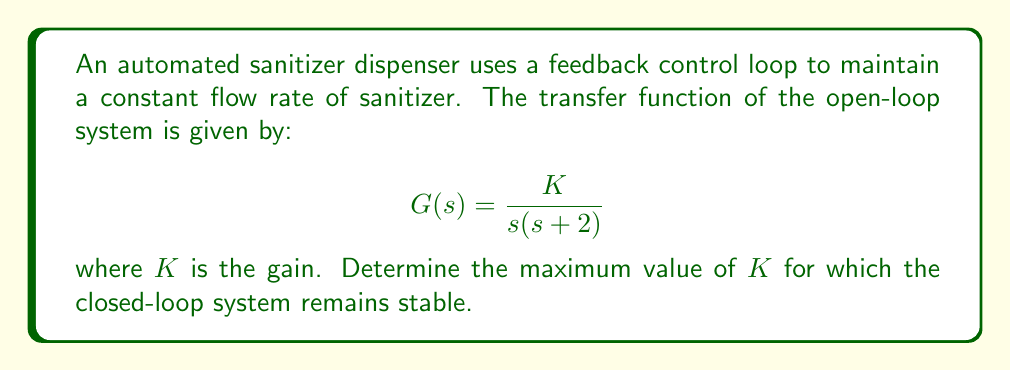Can you solve this math problem? To determine the stability of the closed-loop system, we need to analyze the characteristic equation using the Routh-Hurwitz stability criterion. 

1. First, let's form the closed-loop transfer function:

   $$H(s) = \frac{G(s)}{1 + G(s)} = \frac{\frac{K}{s(s + 2)}}{1 + \frac{K}{s(s + 2)}} = \frac{K}{s^2 + 2s + K}$$

2. The characteristic equation is the denominator of $H(s)$ set to zero:

   $$s^2 + 2s + K = 0$$

3. Now, we form the Routh array:

   $$\begin{array}{c|c}
   s^2 & 1 & K \\
   s^1 & 2 & 0 \\
   s^0 & K & 0
   \end{array}$$

4. For stability, all elements in the first column of the Routh array must be positive. We already know that the first two elements (1 and 2) are positive. The system will be stable as long as the last element, $K$, is also positive.

5. Therefore, the stability condition is:

   $$K > 0$$

6. To find the maximum value of $K$, we need to consider the border of stability. The system becomes marginally stable when $K$ approaches infinity. However, in practice, we want to maintain a safety margin.

7. A common rule of thumb is to use a gain margin of 6 dB, which corresponds to a factor of 2. This means we should set the maximum $K$ to half of the theoretical maximum.

8. Since the theoretical maximum is infinity, we can choose a large value for $K$, such as 1000, and then halve it for practical stability.
Answer: The maximum value of $K$ for which the closed-loop system remains stable is theoretically any positive value. However, for practical stability with a 6 dB gain margin, a recommended maximum value would be $K = 500$. 